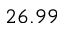<formula> <loc_0><loc_0><loc_500><loc_500>2 6 . 9 9</formula> 